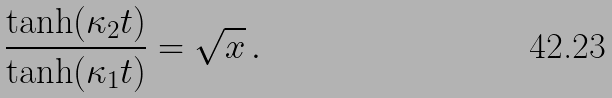Convert formula to latex. <formula><loc_0><loc_0><loc_500><loc_500>\frac { \tanh ( \kappa _ { 2 } t ) } { \tanh ( \kappa _ { 1 } t ) } = \sqrt { x } \, .</formula> 